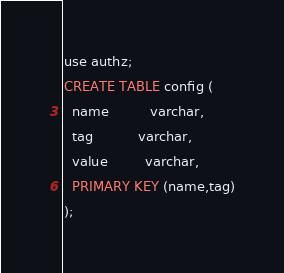Convert code to text. <code><loc_0><loc_0><loc_500><loc_500><_SQL_>use authz;
CREATE TABLE config (
  name          varchar,
  tag           varchar,
  value         varchar,
  PRIMARY KEY (name,tag)
);
</code> 